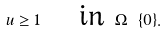<formula> <loc_0><loc_0><loc_500><loc_500>u \geq 1 \quad \text { in } \Omega \ \{ 0 \} .</formula> 